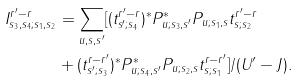Convert formula to latex. <formula><loc_0><loc_0><loc_500><loc_500>I ^ { r ^ { \prime } - r } _ { s _ { 3 } , s _ { 4 } ; s _ { 1 } , s _ { 2 } } & = \sum _ { u , s , s ^ { \prime } } [ ( t ^ { r ^ { \prime } - r } _ { s ^ { \prime } ; s _ { 4 } } ) ^ { * } P ^ { * } _ { u ; s _ { 3 } , s ^ { \prime } } P _ { u ; s _ { 1 } , s } t ^ { r ^ { \prime } - r } _ { s ; s _ { 2 } } \\ & + ( t ^ { r - r ^ { \prime } } _ { s ^ { \prime } ; s _ { 3 } } ) ^ { * } P ^ { * } _ { u ; s _ { 4 } , s ^ { \prime } } P _ { u ; s _ { 2 } , s } t ^ { r - r ^ { \prime } } _ { s ; s _ { 1 } } ] / ( U ^ { \prime } - J ) .</formula> 